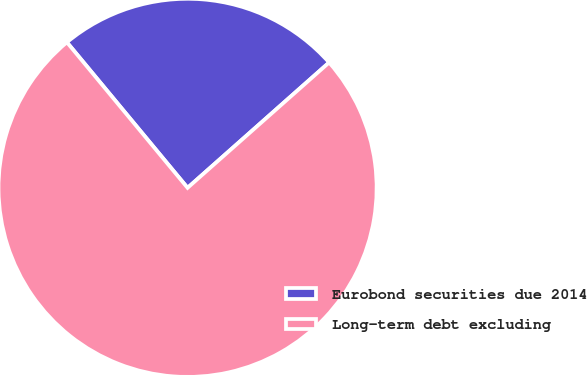Convert chart. <chart><loc_0><loc_0><loc_500><loc_500><pie_chart><fcel>Eurobond securities due 2014<fcel>Long-term debt excluding<nl><fcel>24.48%<fcel>75.52%<nl></chart> 